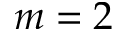Convert formula to latex. <formula><loc_0><loc_0><loc_500><loc_500>m = 2</formula> 